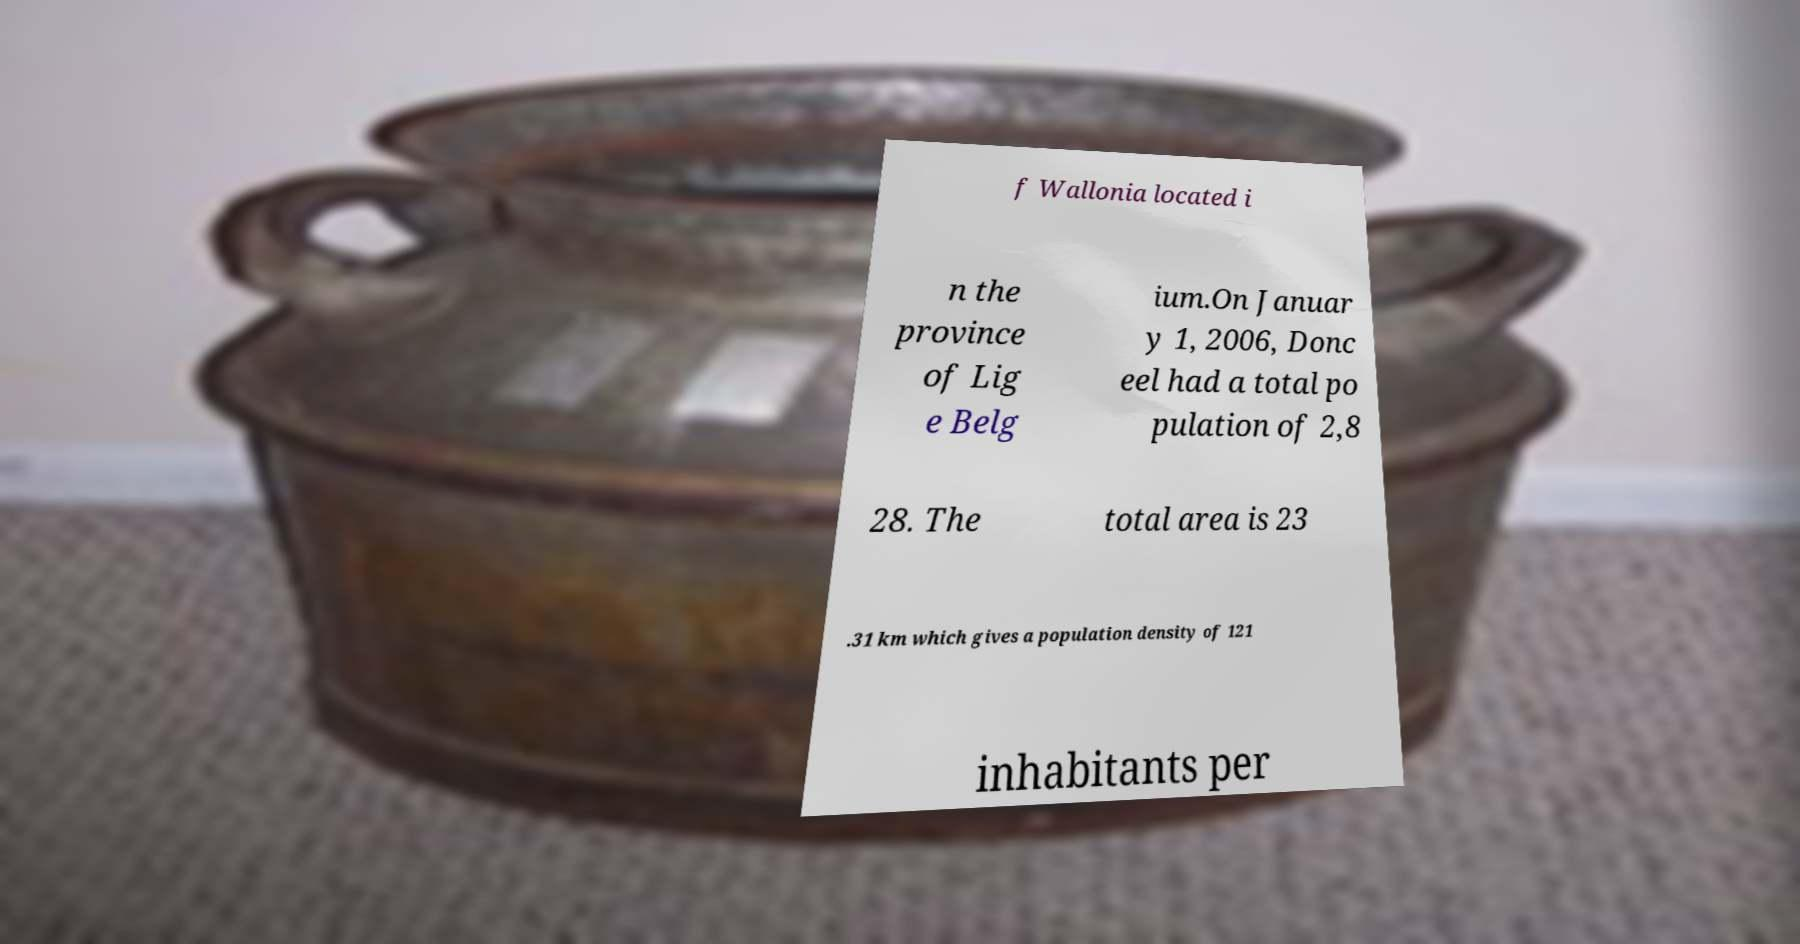I need the written content from this picture converted into text. Can you do that? f Wallonia located i n the province of Lig e Belg ium.On Januar y 1, 2006, Donc eel had a total po pulation of 2,8 28. The total area is 23 .31 km which gives a population density of 121 inhabitants per 